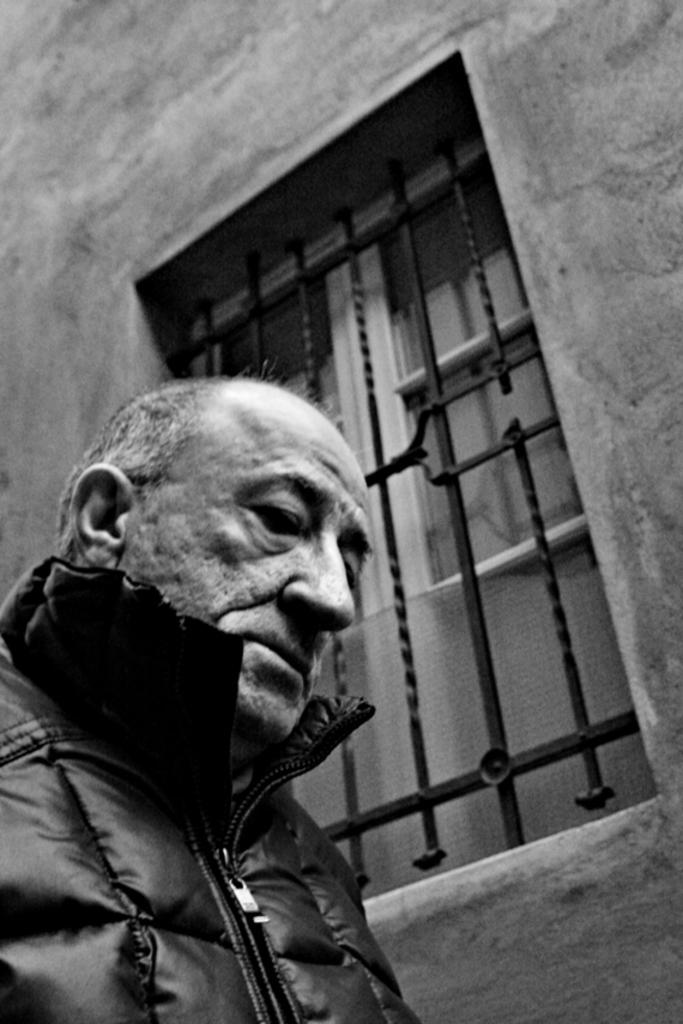Can you describe this image briefly? In this image there is an old man on the left side. There is a wall with a window. There are grills and wooden doors for the window. 